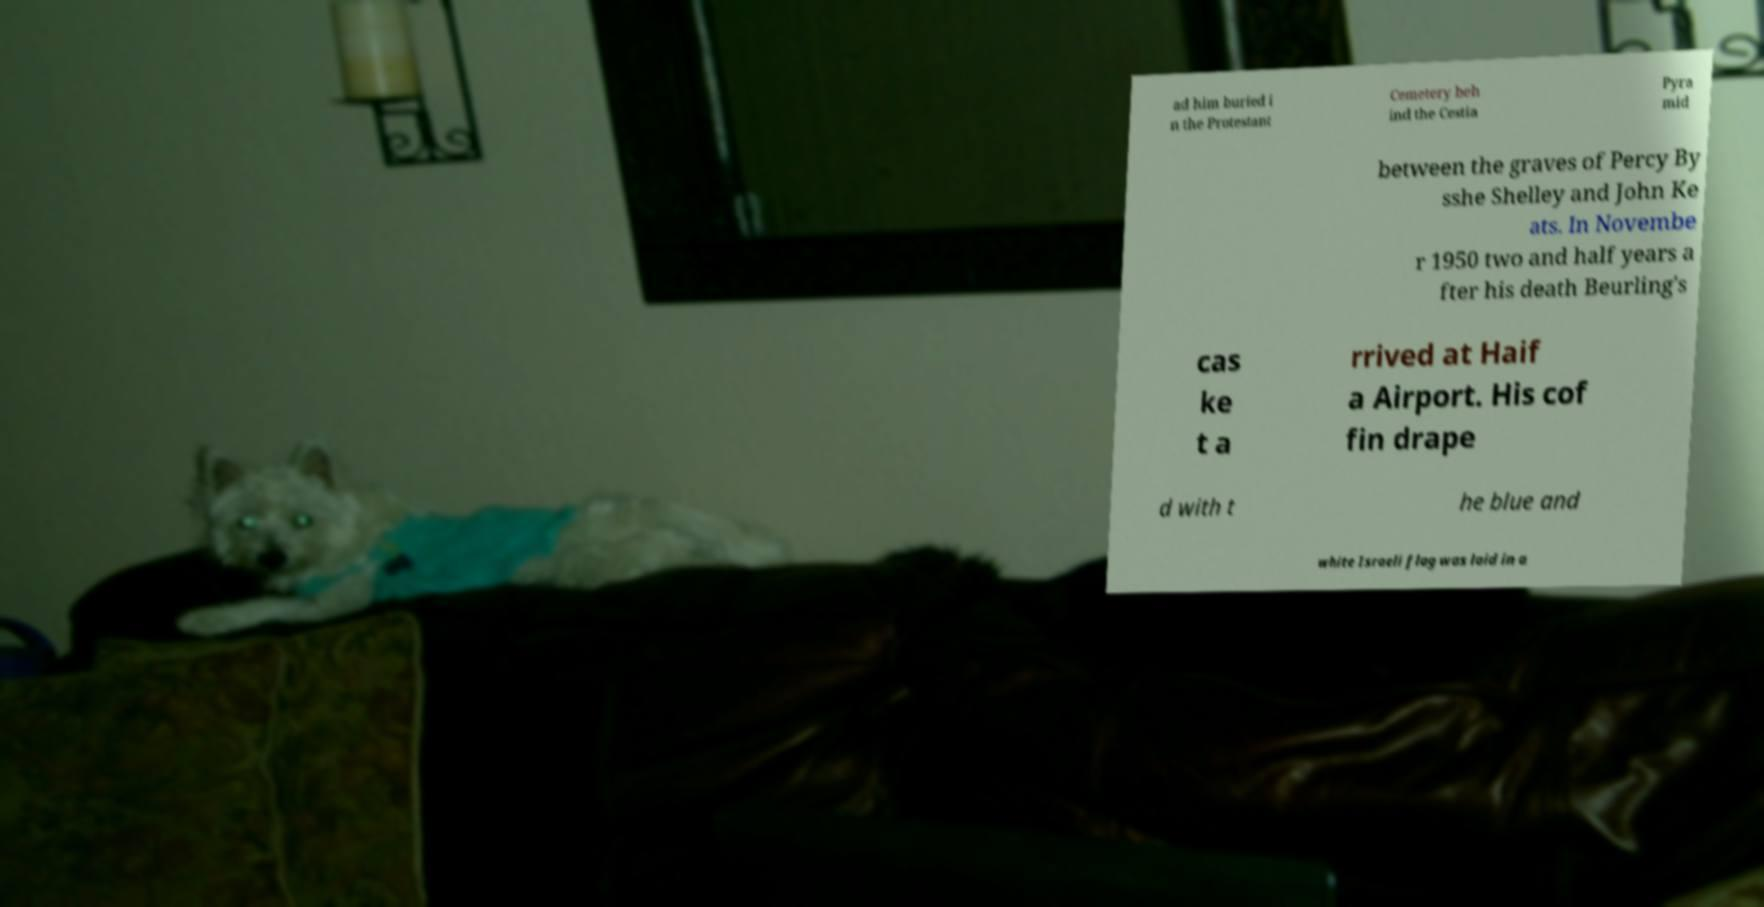Please identify and transcribe the text found in this image. ad him buried i n the Protestant Cemetery beh ind the Cestia Pyra mid between the graves of Percy By sshe Shelley and John Ke ats. In Novembe r 1950 two and half years a fter his death Beurling's cas ke t a rrived at Haif a Airport. His cof fin drape d with t he blue and white Israeli flag was laid in a 